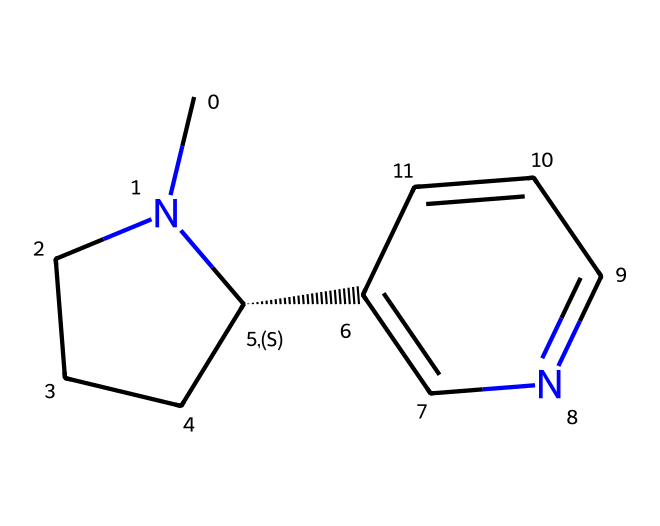How many carbon atoms are in the nicotine molecule? The SMILES representation can be broken down into its individual parts showing each atom present. Counting the 'C' in the structure reveals there are 10 carbon atoms.
Answer: ten How many nitrogen atoms are in the nicotine molecule? By examining the SMILES structure, each occurrence of 'N' points to a nitrogen atom. In this case, we see 2 nitrogen atoms.
Answer: two What is the molecular formula of nicotine? From the SMILES representation, by counting the carbon, hydrogen, and nitrogen atoms, we derive the molecular formula as C10H14N2.
Answer: C10H14N2 What type of functional group is present in nicotine? Observing the structure, specifically the nitrogen atoms, we recognize that nicotine has a basic nitrogen-containing structure, typical of alkaloids.
Answer: alkaloid What impact does nicotine have on the central nervous system? Nicotine acts as a stimulant on the central nervous system, affecting neurotransmitter release and creating addictive properties.
Answer: stimulant How does the stereochemistry of nicotine impact its biological activity? The presence of a chiral center in nicotine allows for different stereoisomers, which can have varying effects on biological systems, enhancing its addictive nature.
Answer: enhances addictiveness What type of receptors does nicotine primarily interact with? Nicotine mainly binds to nicotinic acetylcholine receptors, which are involved in many neurotransmission processes affecting mood and cognition.
Answer: nicotinic acetylcholine receptors 